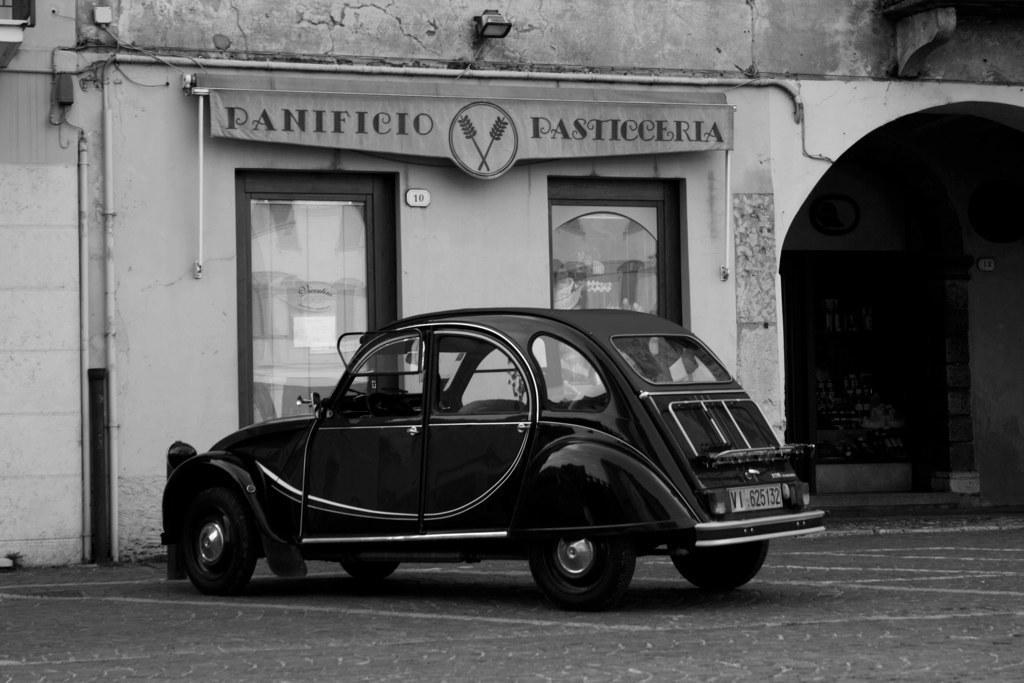Can you describe this image briefly? In this image we can see a car on the surface. Behind the car we can see a wall of a building. On the wall we can see glass doors and some text. At the top we can see a light. On the left side, we can see pipes and wires. 